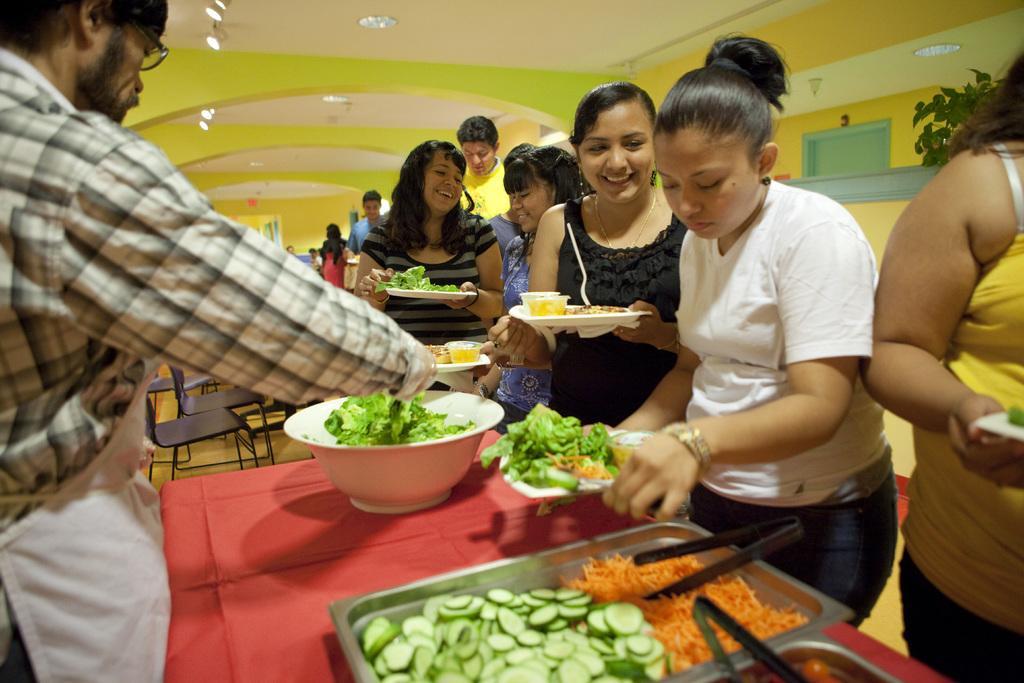Could you give a brief overview of what you see in this image? In this image, we can see persons holding plates with their hands. There is table at the bottom of the image contains dishes and bowl with some vegetables. There is a person on the left side of the image. There lights on the ceiling which at the top of the image. There are chairs in the middle of the image. 